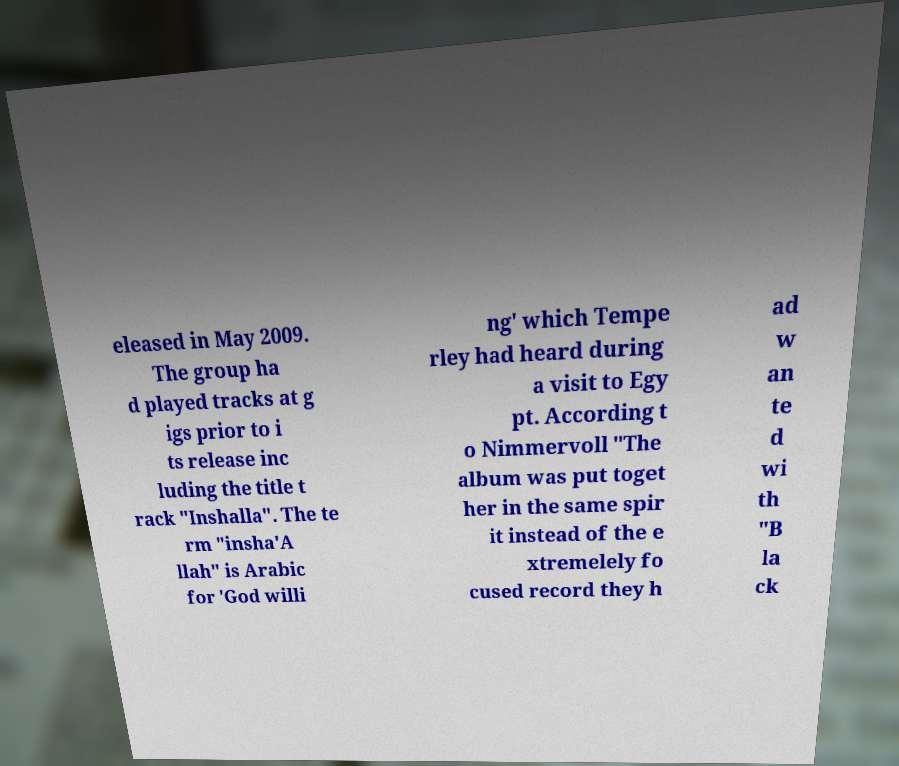Can you accurately transcribe the text from the provided image for me? eleased in May 2009. The group ha d played tracks at g igs prior to i ts release inc luding the title t rack "Inshalla". The te rm "insha'A llah" is Arabic for 'God willi ng' which Tempe rley had heard during a visit to Egy pt. According t o Nimmervoll "The album was put toget her in the same spir it instead of the e xtremelely fo cused record they h ad w an te d wi th "B la ck 